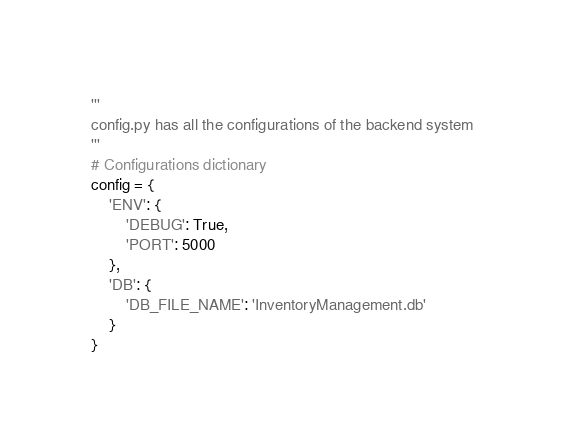Convert code to text. <code><loc_0><loc_0><loc_500><loc_500><_Python_>'''
config.py has all the configurations of the backend system
'''
# Configurations dictionary
config = {
    'ENV': {
        'DEBUG': True,
        'PORT': 5000
    },
    'DB': {
        'DB_FILE_NAME': 'InventoryManagement.db'
    }
}
</code> 